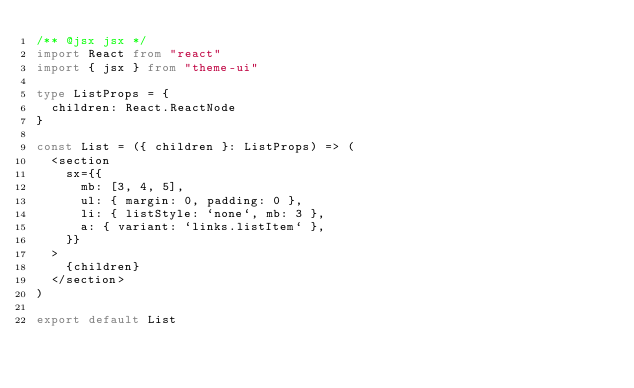<code> <loc_0><loc_0><loc_500><loc_500><_TypeScript_>/** @jsx jsx */
import React from "react"
import { jsx } from "theme-ui"

type ListProps = {
  children: React.ReactNode
}

const List = ({ children }: ListProps) => (
  <section
    sx={{
      mb: [3, 4, 5],
      ul: { margin: 0, padding: 0 },
      li: { listStyle: `none`, mb: 3 },
      a: { variant: `links.listItem` },
    }}
  >
    {children}
  </section>
)

export default List
</code> 